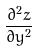<formula> <loc_0><loc_0><loc_500><loc_500>\frac { \partial ^ { 2 } z } { \partial y ^ { 2 } }</formula> 